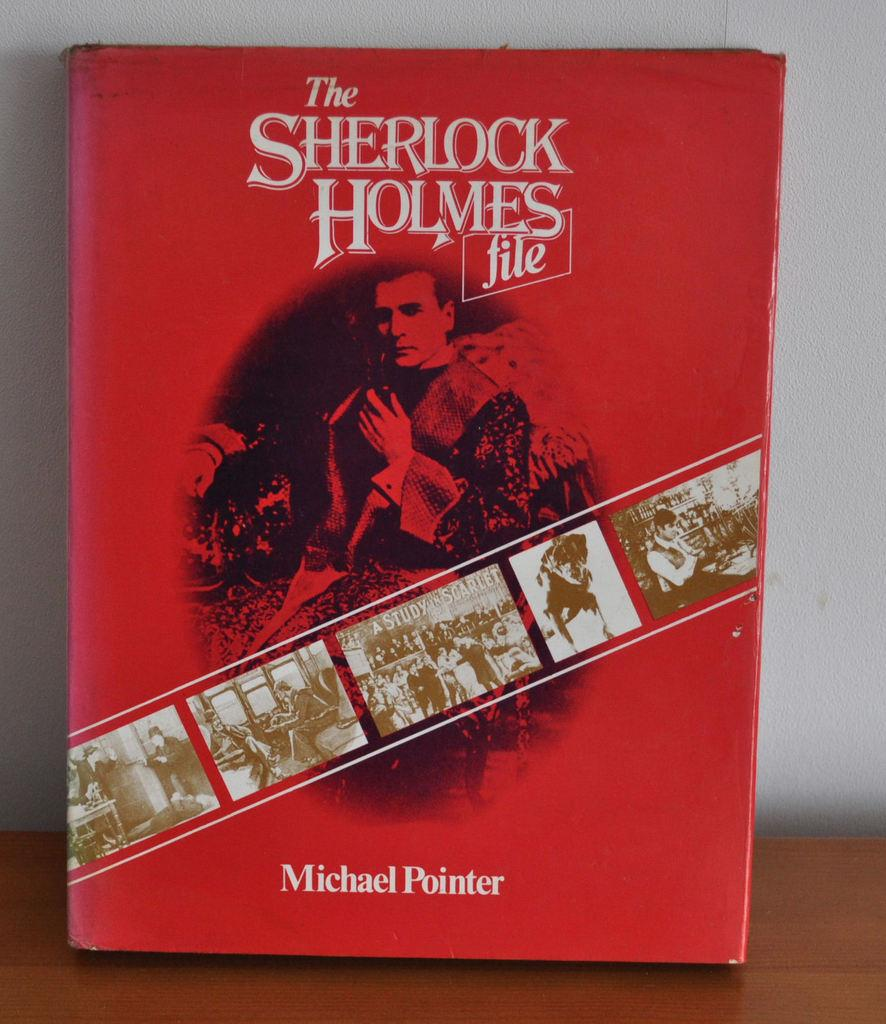Provide a one-sentence caption for the provided image. The red cover of a Sherlock Holmes book. 